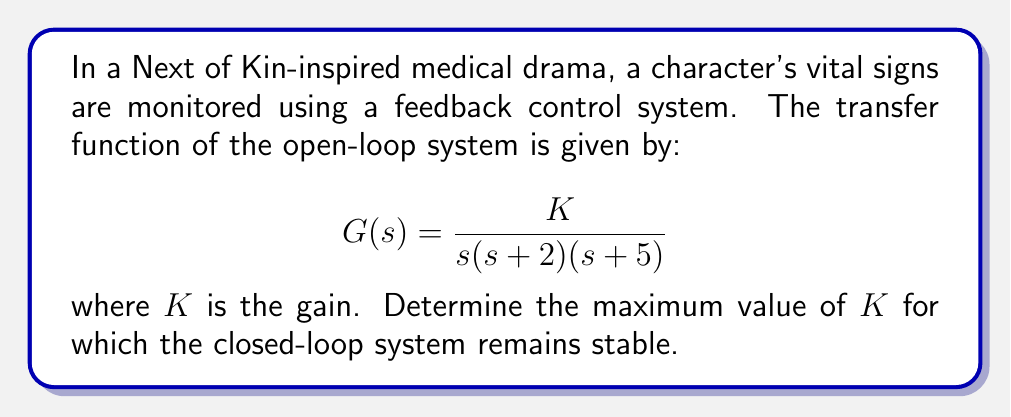Help me with this question. To analyze the stability of the closed-loop system, we'll use the Routh-Hurwitz stability criterion. First, let's derive the characteristic equation of the closed-loop system:

1) The closed-loop transfer function is:
   $$T(s) = \frac{G(s)}{1 + G(s)} = \frac{K}{s(s+2)(s+5) + K}$$

2) The characteristic equation is:
   $$s(s+2)(s+5) + K = 0$$
   $$s^3 + 7s^2 + 10s + K = 0$$

3) Now, let's construct the Routh array:
   $$\begin{array}{c|c}
   s^3 & 1 & 10 \\
   s^2 & 7 & K \\
   s^1 & \frac{70-K}{7} & 0 \\
   s^0 & K
   \end{array}$$

4) For stability, all elements in the first column must be positive. We already know that 1 and 7 are positive, so we need:

   $$\frac{70-K}{7} > 0 \quad \text{and} \quad K > 0$$

5) From the first inequality:
   $$70-K > 0$$
   $$K < 70$$

6) Combining this with $K > 0$, we get:
   $$0 < K < 70$$

Therefore, the maximum value of $K$ for which the system remains stable is just under 70.
Answer: The maximum value of $K$ for which the closed-loop system remains stable is 70 (exclusive). 